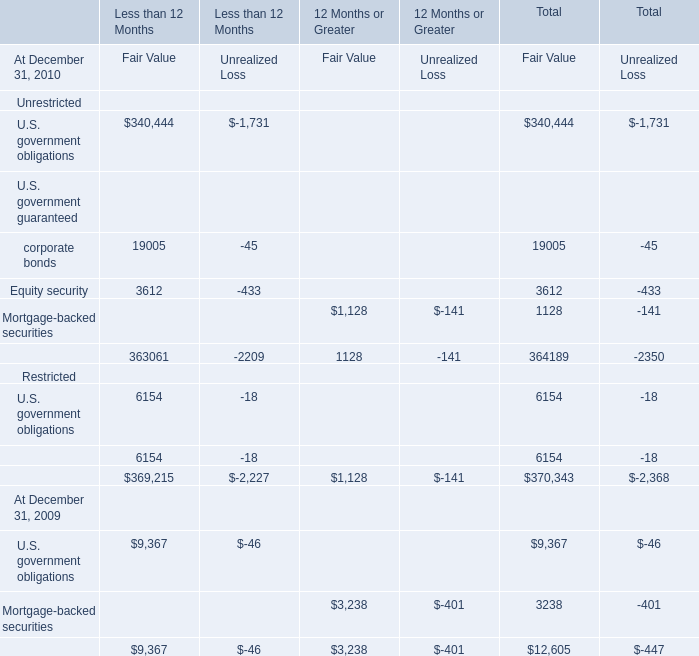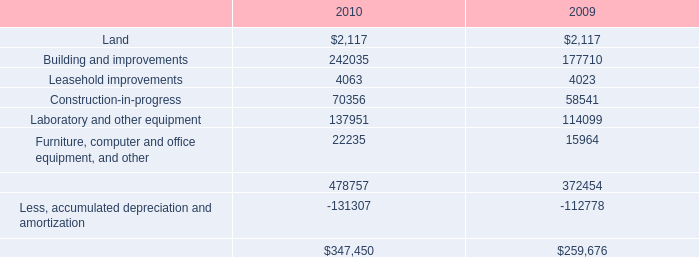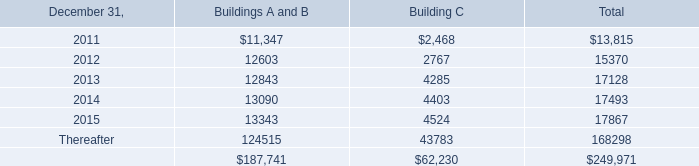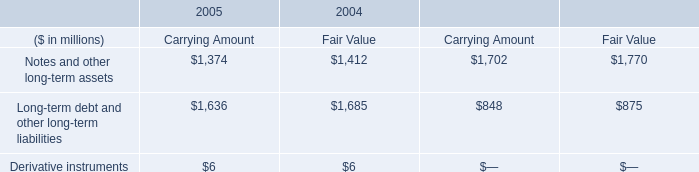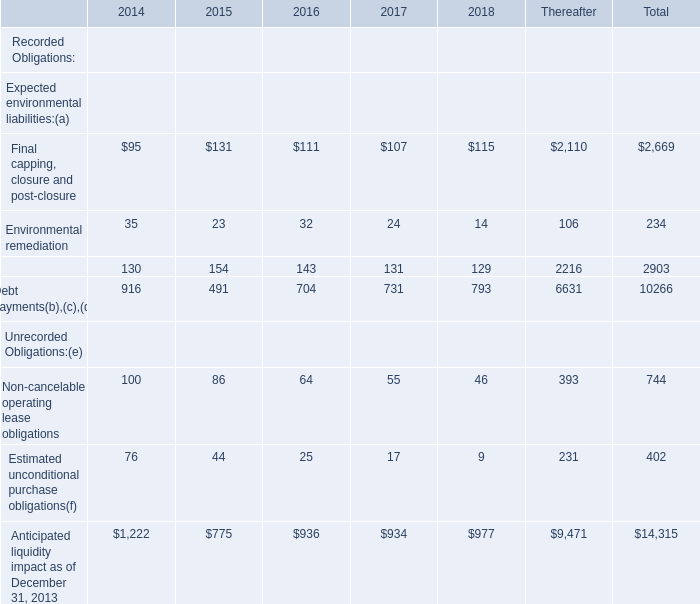What is the sum of the Unrecorded Obligations:(e):Non-cancelable operating lease obligations in the years where Expected environmental liabilities:(a):Final capping, closure and post-closure is positive? 
Computations: ((((100 + 86) + 64) + 55) + 46)
Answer: 351.0. 